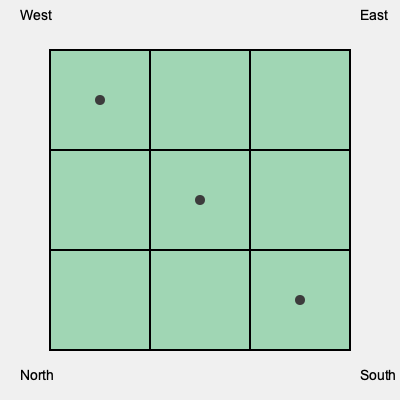Given the top-down map of a coffee plantation above, which of the following perspective views would best represent the terrain when viewed from the southwest corner?

A) A gradual upward slope from southwest to northeast
B) A flat terrain with no elevation changes
C) A series of terraced levels increasing in height from southwest to northeast
D) A steep cliff face rising from southwest to northeast To determine the correct perspective view of the coffee plantation, we need to analyze the given top-down map:

1. The map is divided into a 3x3 grid, representing different sections of the plantation.

2. There are three black dots on the map, positioned diagonally from the southwest to the northeast corner.

3. These dots likely represent elevation markers or key points on the terrain.

4. The positioning of these dots suggests a gradual increase in elevation from southwest to northeast:
   - First dot: bottom-left (southwest) corner
   - Second dot: center of the map
   - Third dot: top-right (northeast) corner

5. This pattern indicates a consistent increase in elevation across the plantation.

6. Given that coffee plantations often utilize sloped terrain for optimal growing conditions, we can infer that the land gradually rises from southwest to northeast.

7. The gradual placement of the dots rules out options B (flat terrain) and D (steep cliff face).

8. While terraced levels (option C) are sometimes used in coffee plantations, the evenly spaced dots suggest a more uniform slope rather than distinct terraces.

Therefore, the most accurate representation of the terrain when viewed from the southwest corner would be a gradual upward slope from southwest to northeast.
Answer: A) A gradual upward slope from southwest to northeast 